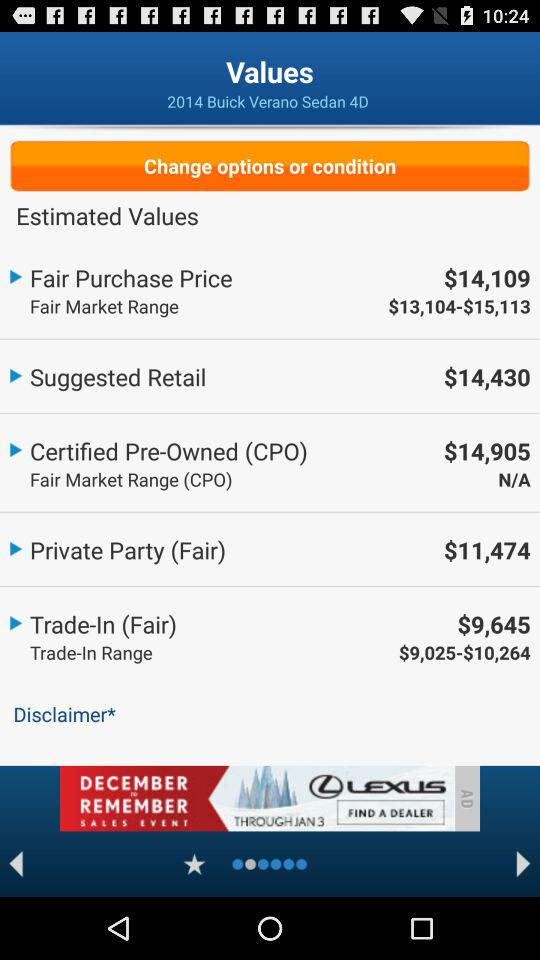What is the "Private Party (Fair)" price? The price is $11,474. 